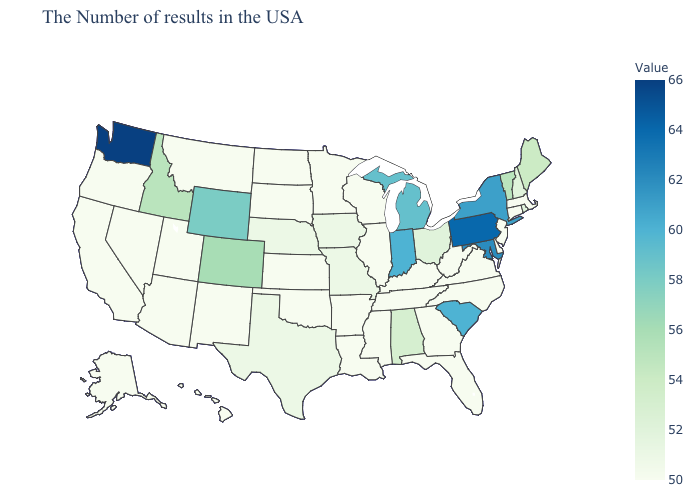Among the states that border Arkansas , which have the highest value?
Write a very short answer. Missouri, Texas. Which states have the lowest value in the MidWest?
Be succinct. Wisconsin, Illinois, Minnesota, Kansas, South Dakota, North Dakota. Does Alaska have the lowest value in the West?
Answer briefly. Yes. Is the legend a continuous bar?
Short answer required. Yes. Does Texas have the lowest value in the USA?
Answer briefly. No. Which states have the lowest value in the USA?
Answer briefly. Massachusetts, Connecticut, New Jersey, Delaware, Virginia, North Carolina, West Virginia, Florida, Georgia, Kentucky, Tennessee, Wisconsin, Illinois, Mississippi, Louisiana, Arkansas, Minnesota, Kansas, Oklahoma, South Dakota, North Dakota, New Mexico, Utah, Montana, Arizona, Nevada, California, Oregon, Alaska, Hawaii. 